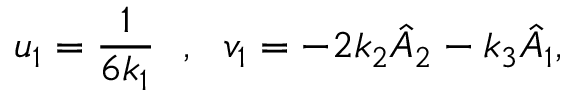Convert formula to latex. <formula><loc_0><loc_0><loc_500><loc_500>u _ { 1 } = \frac { 1 } { 6 k _ { 1 } } , v _ { 1 } = - 2 k _ { 2 } \hat { A } _ { 2 } - k _ { 3 } \hat { A } _ { 1 } ,</formula> 